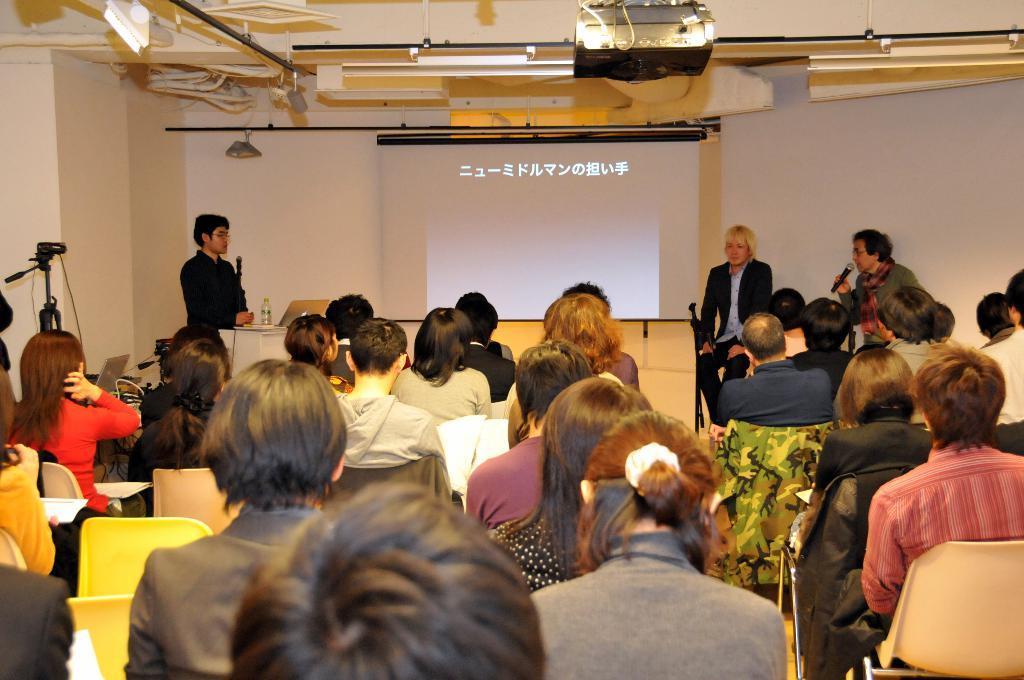Describe this image in one or two sentences. In this image, we can see people and some are sitting on the chairs and there is a person holding a mic. In the background, there are lights, a screen with some text and there is a bottle, laptop and some other objects on the stand. 